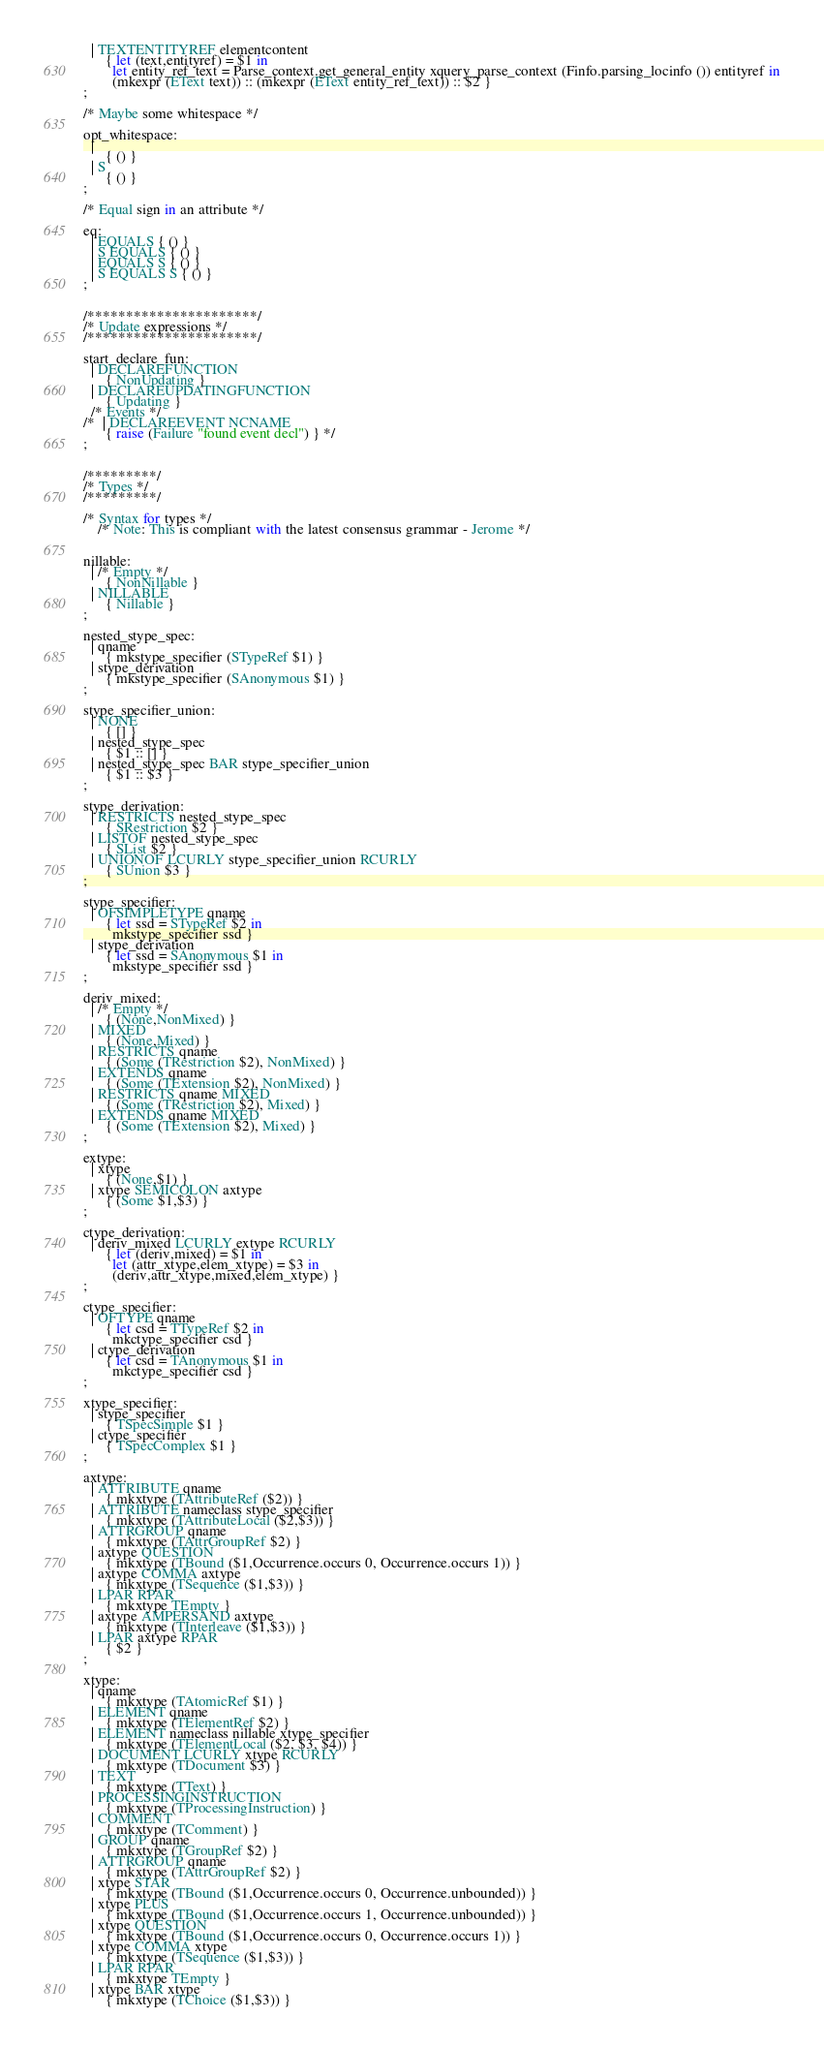<code> <loc_0><loc_0><loc_500><loc_500><_OCaml_>  | TEXTENTITYREF elementcontent
      { let (text,entityref) = $1 in
        let entity_ref_text = Parse_context.get_general_entity xquery_parse_context (Finfo.parsing_locinfo ()) entityref in
        (mkexpr (EText text)) :: (mkexpr (EText entity_ref_text)) :: $2 } 
;

/* Maybe some whitespace */

opt_whitespace:
  |
      { () }
  | S
      { () }
;

/* Equal sign in an attribute */

eq:
  | EQUALS { () }
  | S EQUALS { () }
  | EQUALS S { () }
  | S EQUALS S { () }
;


/**********************/
/* Update expressions */
/**********************/

start_declare_fun:
  | DECLAREFUNCTION
      { NonUpdating }
  | DECLAREUPDATINGFUNCTION
      { Updating }
  /* Events */
/*  | DECLAREEVENT NCNAME 
      { raise (Failure "found event decl") } */
;


/*********/
/* Types */
/*********/
  
/* Syntax for types */
    /* Note: This is compliant with the latest consensus grammar - Jerome */
	

nillable:
  | /* Empty */
      { NonNillable }
  | NILLABLE
      { Nillable }
;

nested_stype_spec:
  | qname
      { mkstype_specifier (STypeRef $1) }
  | stype_derivation
      { mkstype_specifier (SAnonymous $1) }
;

stype_specifier_union:
  | NONE
      { [] }
  | nested_stype_spec
      { $1 :: [] }
  | nested_stype_spec BAR stype_specifier_union
      { $1 :: $3 }
;

stype_derivation:
  | RESTRICTS nested_stype_spec
      { SRestriction $2 }
  | LISTOF nested_stype_spec
      { SList $2 }
  | UNIONOF LCURLY stype_specifier_union RCURLY
      { SUnion $3 }
;

stype_specifier:
  | OFSIMPLETYPE qname
      { let ssd = STypeRef $2 in
        mkstype_specifier ssd }
  | stype_derivation
      { let ssd = SAnonymous $1 in
        mkstype_specifier ssd }
;

deriv_mixed:
  | /* Empty */
      { (None,NonMixed) }
  | MIXED
      { (None,Mixed) }
  | RESTRICTS qname
      { (Some (TRestriction $2), NonMixed) }
  | EXTENDS qname
      { (Some (TExtension $2), NonMixed) }
  | RESTRICTS qname MIXED
      { (Some (TRestriction $2), Mixed) }
  | EXTENDS qname MIXED
      { (Some (TExtension $2), Mixed) }
;

extype:
  | xtype
      { (None,$1) }
  | xtype SEMICOLON axtype
      { (Some $1,$3) }
;

ctype_derivation:
  | deriv_mixed LCURLY extype RCURLY
      { let (deriv,mixed) = $1 in
        let (attr_xtype,elem_xtype) = $3 in
        (deriv,attr_xtype,mixed,elem_xtype) }
;

ctype_specifier:
  | OFTYPE qname
      { let csd = TTypeRef $2 in
        mkctype_specifier csd }
  | ctype_derivation
      { let csd = TAnonymous $1 in
        mkctype_specifier csd }
;

xtype_specifier:
  | stype_specifier
      { TSpecSimple $1 }
  | ctype_specifier
      { TSpecComplex $1 }
;

axtype:
  | ATTRIBUTE qname
      { mkxtype (TAttributeRef ($2)) }
  | ATTRIBUTE nameclass stype_specifier
      { mkxtype (TAttributeLocal ($2,$3)) }
  | ATTRGROUP qname
      { mkxtype (TAttrGroupRef $2) }
  | axtype QUESTION
      { mkxtype (TBound ($1,Occurrence.occurs 0, Occurrence.occurs 1)) }
  | axtype COMMA axtype
      { mkxtype (TSequence ($1,$3)) }
  | LPAR RPAR
      { mkxtype TEmpty }
  | axtype AMPERSAND axtype
      { mkxtype (TInterleave ($1,$3)) }
  | LPAR axtype RPAR
      { $2 }
;

xtype:
  | qname
      { mkxtype (TAtomicRef $1) }
  | ELEMENT qname
      { mkxtype (TElementRef $2) } 
  | ELEMENT nameclass nillable xtype_specifier
      { mkxtype (TElementLocal ($2, $3, $4)) } 
  | DOCUMENT LCURLY xtype RCURLY
      { mkxtype (TDocument $3) }
  | TEXT
      { mkxtype (TText) }
  | PROCESSINGINSTRUCTION
      { mkxtype (TProcessingInstruction) }
  | COMMENT
      { mkxtype (TComment) }
  | GROUP qname
      { mkxtype (TGroupRef $2) }
  | ATTRGROUP qname
      { mkxtype (TAttrGroupRef $2) }
  | xtype STAR
      { mkxtype (TBound ($1,Occurrence.occurs 0, Occurrence.unbounded)) }
  | xtype PLUS
      { mkxtype (TBound ($1,Occurrence.occurs 1, Occurrence.unbounded)) }
  | xtype QUESTION
      { mkxtype (TBound ($1,Occurrence.occurs 0, Occurrence.occurs 1)) }
  | xtype COMMA xtype
      { mkxtype (TSequence ($1,$3)) }
  | LPAR RPAR
      { mkxtype TEmpty }
  | xtype BAR xtype
      { mkxtype (TChoice ($1,$3)) }</code> 